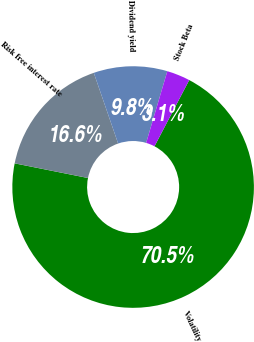Convert chart. <chart><loc_0><loc_0><loc_500><loc_500><pie_chart><fcel>Volatility<fcel>Risk free interest rate<fcel>Dividend yield<fcel>Stock Beta<nl><fcel>70.46%<fcel>16.58%<fcel>9.85%<fcel>3.12%<nl></chart> 